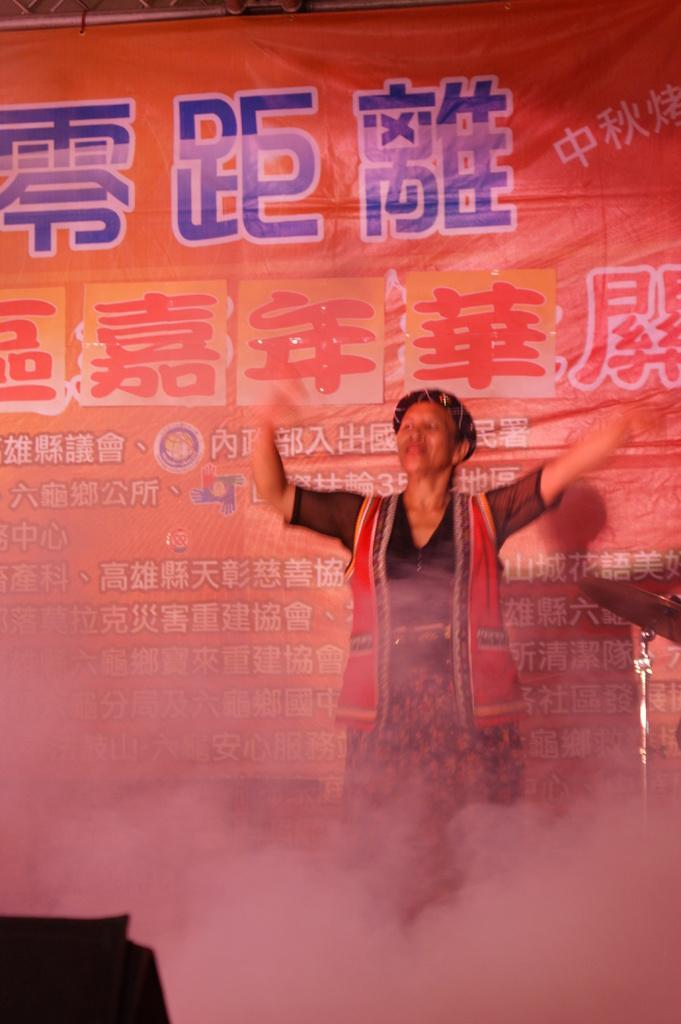Could you give a brief overview of what you see in this image? There is a person dancing. There is smoke. In the background there is a banner with something written. 